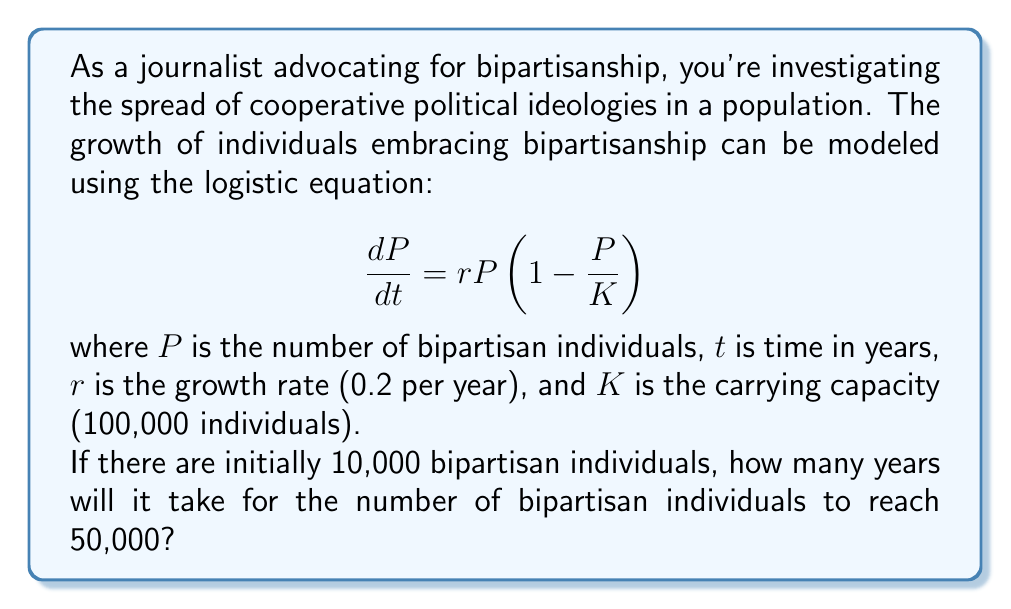Teach me how to tackle this problem. To solve this problem, we need to use the solution to the logistic differential equation:

$$P(t) = \frac{K}{1 + (\frac{K}{P_0} - 1)e^{-rt}}$$

Where $P_0$ is the initial population.

Given:
$K = 100,000$
$r = 0.2$
$P_0 = 10,000$
$P(t) = 50,000$ (the target population)

Let's substitute these values into the equation:

$$50,000 = \frac{100,000}{1 + (\frac{100,000}{10,000} - 1)e^{-0.2t}}$$

Simplify:

$$50,000 = \frac{100,000}{1 + 9e^{-0.2t}}$$

Multiply both sides by the denominator:

$$50,000(1 + 9e^{-0.2t}) = 100,000$$

Distribute:

$$50,000 + 450,000e^{-0.2t} = 100,000$$

Subtract 50,000 from both sides:

$$450,000e^{-0.2t} = 50,000$$

Divide both sides by 450,000:

$$e^{-0.2t} = \frac{1}{9}$$

Take the natural log of both sides:

$$-0.2t = \ln(\frac{1}{9})$$

$$-0.2t = -\ln(9)$$

Divide both sides by -0.2:

$$t = \frac{\ln(9)}{0.2}$$

Calculate the final result:

$$t \approx 11.0353$$

Therefore, it will take approximately 11.04 years for the number of bipartisan individuals to reach 50,000.
Answer: 11.04 years 